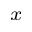Convert formula to latex. <formula><loc_0><loc_0><loc_500><loc_500>_ { x }</formula> 